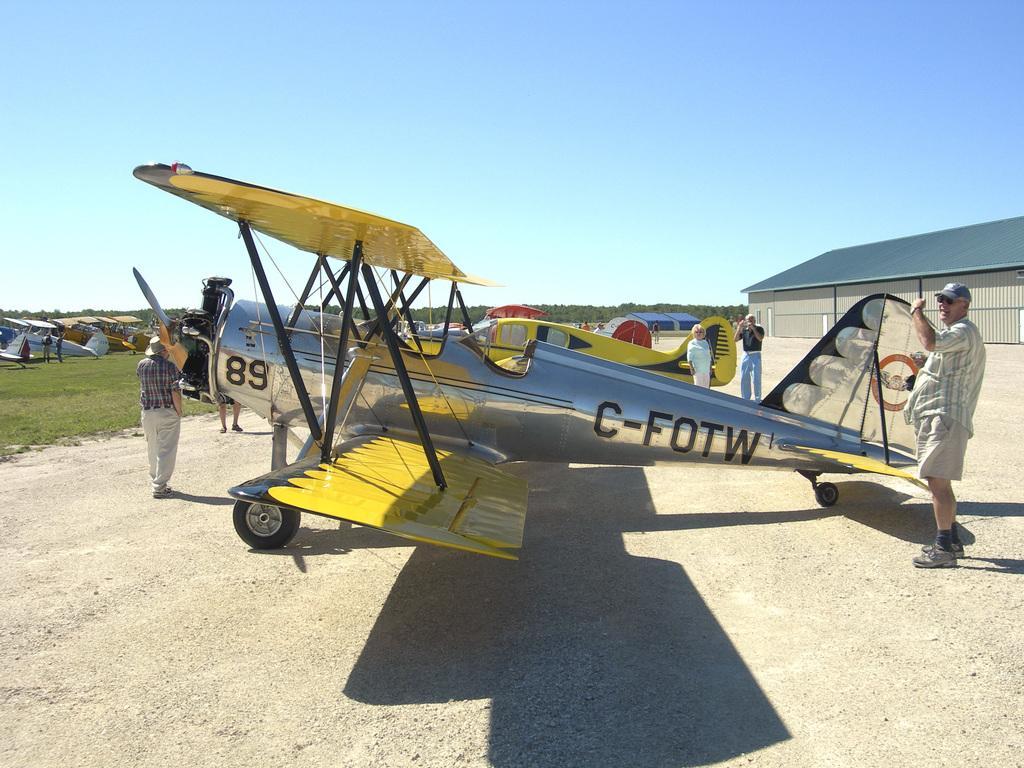In one or two sentences, can you explain what this image depicts? In this image we can see few persons are standing and walking on the ground at the planes which are also on the ground. In the background we can see few persons are standing at the planes, trees, house, roof and sky. 